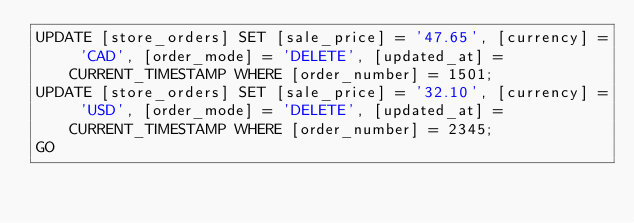<code> <loc_0><loc_0><loc_500><loc_500><_SQL_>UPDATE [store_orders] SET [sale_price] = '47.65', [currency] = 'CAD', [order_mode] = 'DELETE', [updated_at] = CURRENT_TIMESTAMP WHERE [order_number] = 1501;
UPDATE [store_orders] SET [sale_price] = '32.10', [currency] = 'USD', [order_mode] = 'DELETE', [updated_at] = CURRENT_TIMESTAMP WHERE [order_number] = 2345;
GO</code> 